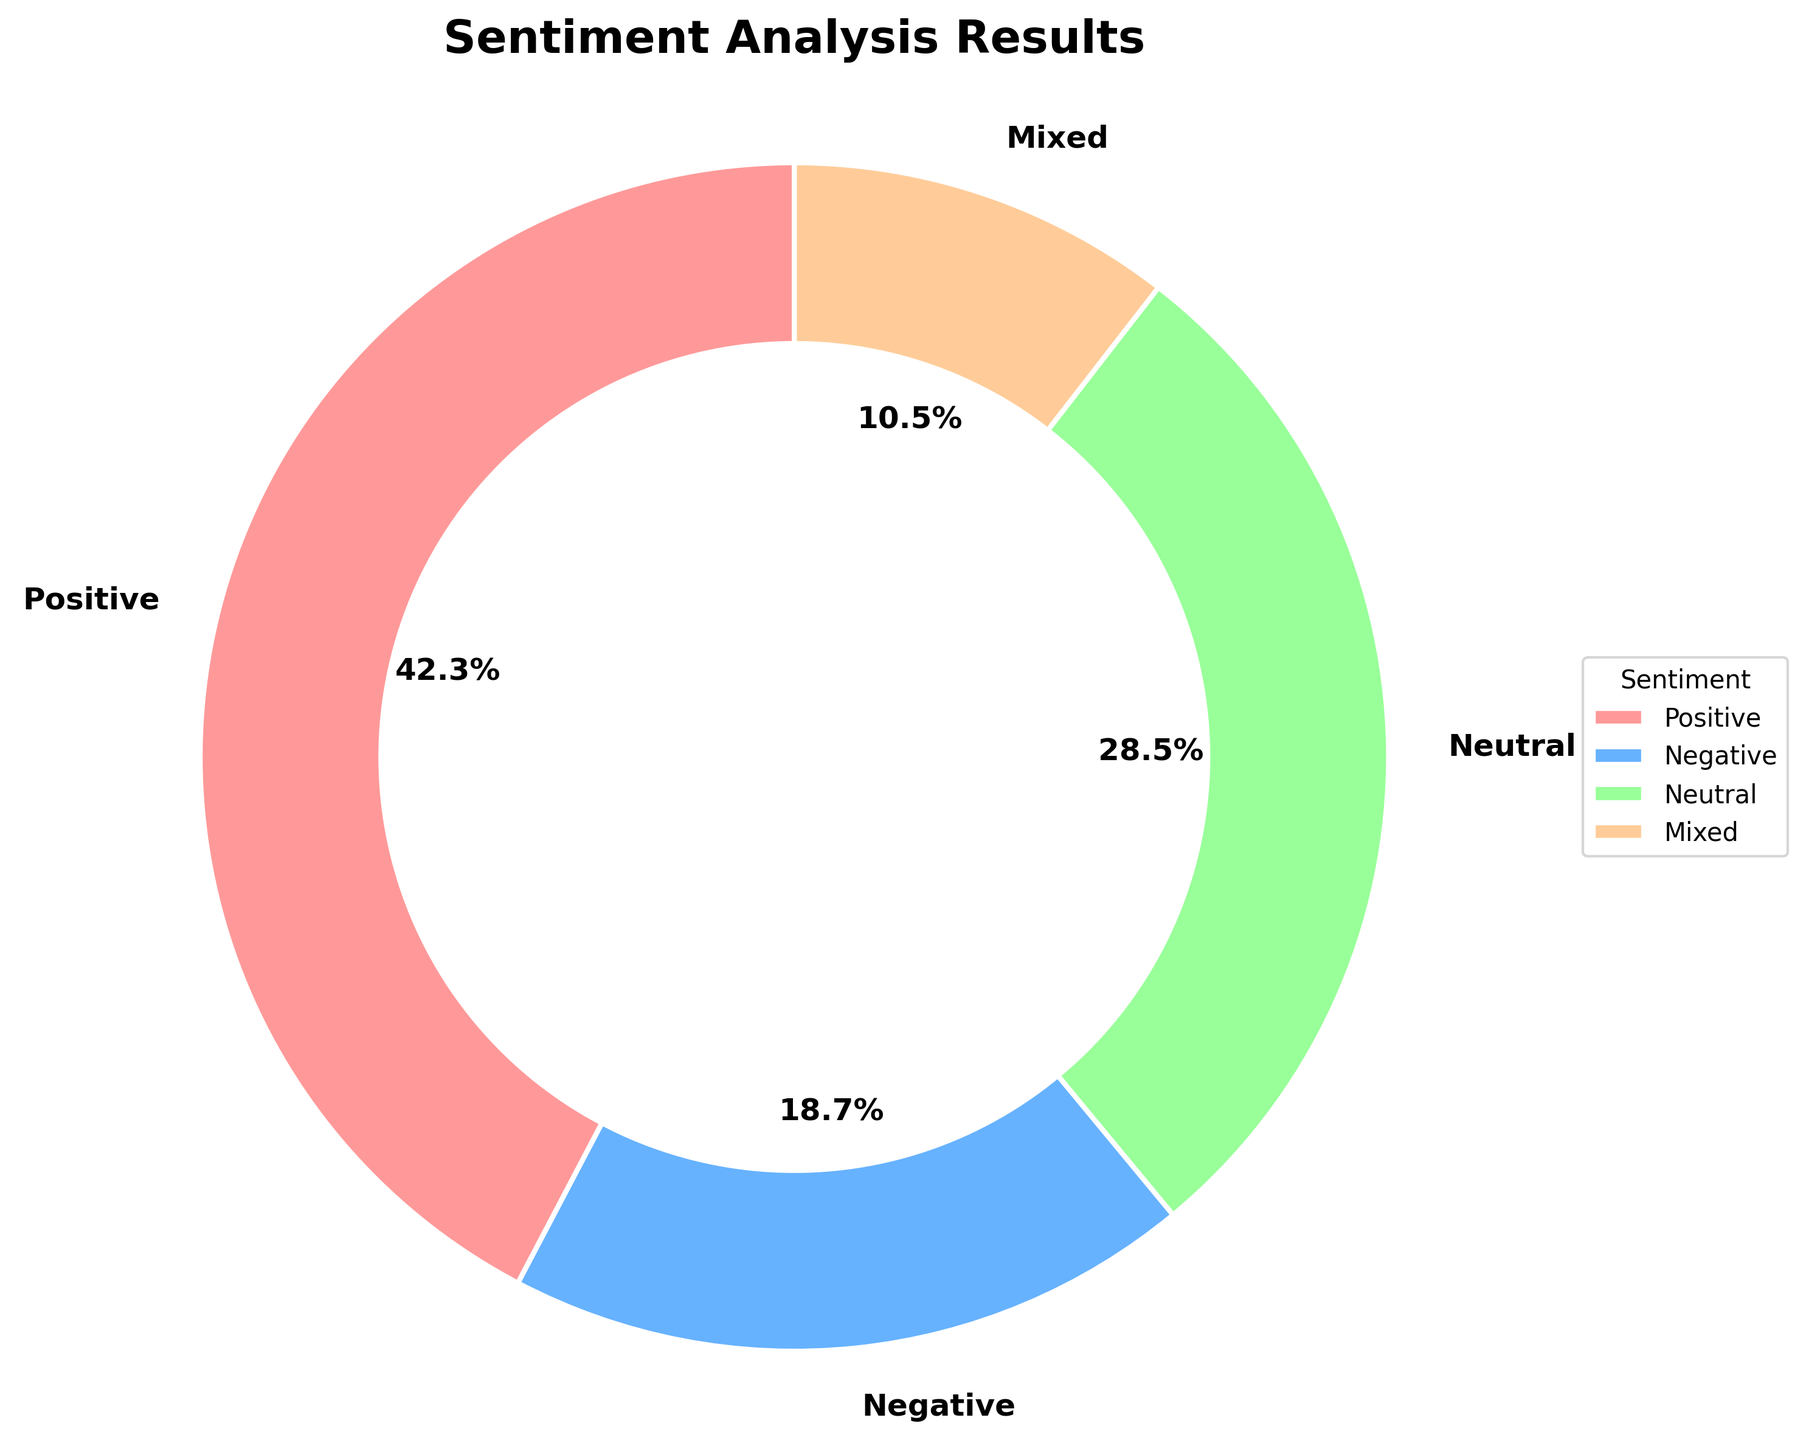What percentage of feedback was neutral or mixed? The neutral feedback is 28.5% and mixed feedback is 10.5%. Summing them up gives 28.5 + 10.5 = 39.0%.
Answer: 39.0% Which sentiment category has the lowest percentage? The four categories are Positive (42.3%), Negative (18.7%), Neutral (28.5%), and Mixed (10.5%). The lowest percentage among these is Mixed with 10.5%.
Answer: Mixed How does the percentage of positive feedback compare to the percentage of negative feedback? The positive feedback is 42.3% and the negative feedback is 18.7%. Positive feedback is higher than negative feedback.
Answer: Positive feedback is higher Are there more neutral or negative feedbacks? The neutral feedback is 28.5% and the negative feedback is 18.7%. By comparing these percentages, there are more neutral feedbacks.
Answer: More neutral feedbacks What is the combined percentage of positive and negative feedback? The positive feedback is 42.3% and the negative feedback is 18.7%. Summing them up gives 42.3 + 18.7 = 61.0%.
Answer: 61.0% Which color represents the neutral feedback? The neutral feedback is represented by a slice labeled "Neutral" in the pie chart. The chart uses a distinct color for each slice, with the color for neutral being green (based on the provided color descriptions).
Answer: Green What is the difference between the highest and lowest sentiment percentages? The highest sentiment percentage is Positive at 42.3%, and the lowest is Mixed at 10.5%. The difference is 42.3 - 10.5 = 31.8%.
Answer: 31.8% Is the percentage of mixed feedback more than a quarter of the total feedback? A quarter of the total feedback is 25%. The mixed feedback is 10.5%, which is less than 25%.
Answer: No If the total number of feedbacks is 200, how many feedbacks are positive? If 42.3% of the 200 feedbacks are positive, then the number of positive feedbacks is (42.3/100) * 200 = 84.6 ≈ 85.
Answer: 85 